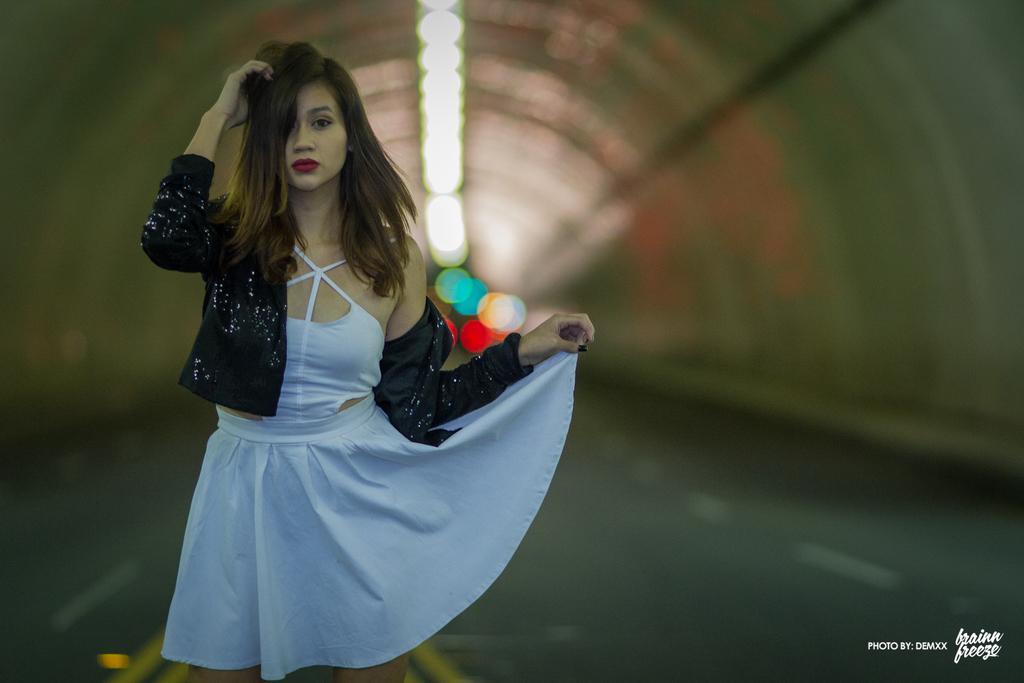Describe this image in one or two sentences. Here in this picture we can see a woman standing on the road over there and we can see she is standing in a tunnel and we can see lights on the top and she is wearing black colored coat on her. 